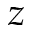Convert formula to latex. <formula><loc_0><loc_0><loc_500><loc_500>z</formula> 